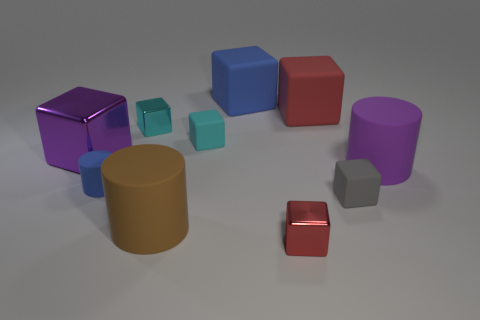Is there a metal cube right of the small metallic thing behind the red cube in front of the tiny cyan metallic cube?
Offer a terse response. Yes. There is a big brown object; what shape is it?
Offer a very short reply. Cylinder. Are the big purple object that is to the right of the small cyan metallic thing and the cylinder to the left of the cyan metal thing made of the same material?
Offer a very short reply. Yes. What number of cylinders are the same color as the large shiny cube?
Keep it short and to the point. 1. The large thing that is both in front of the big metal thing and to the left of the small gray thing has what shape?
Give a very brief answer. Cylinder. The large block that is on the right side of the tiny cylinder and in front of the blue block is what color?
Your answer should be compact. Red. Are there more rubber cylinders that are left of the gray rubber block than blue objects behind the blue block?
Keep it short and to the point. Yes. The tiny shiny cube that is on the right side of the large blue block is what color?
Your response must be concise. Red. Is the shape of the big purple thing right of the large blue matte thing the same as the large object that is in front of the blue cylinder?
Provide a succinct answer. Yes. Is there another gray thing that has the same size as the gray object?
Offer a very short reply. No. 